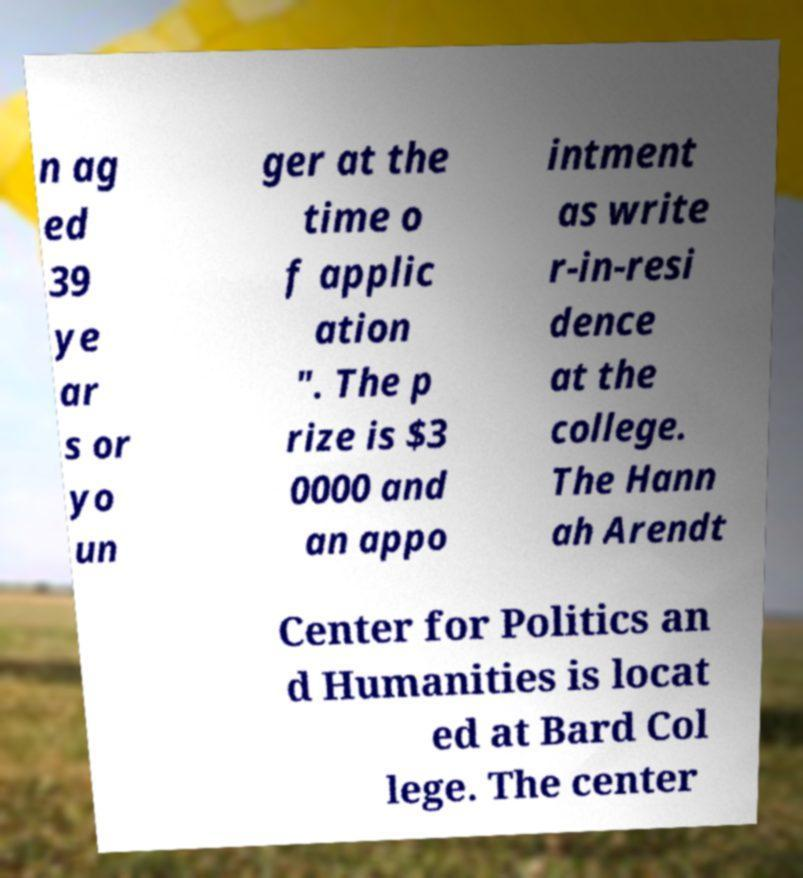Please identify and transcribe the text found in this image. n ag ed 39 ye ar s or yo un ger at the time o f applic ation ". The p rize is $3 0000 and an appo intment as write r-in-resi dence at the college. The Hann ah Arendt Center for Politics an d Humanities is locat ed at Bard Col lege. The center 